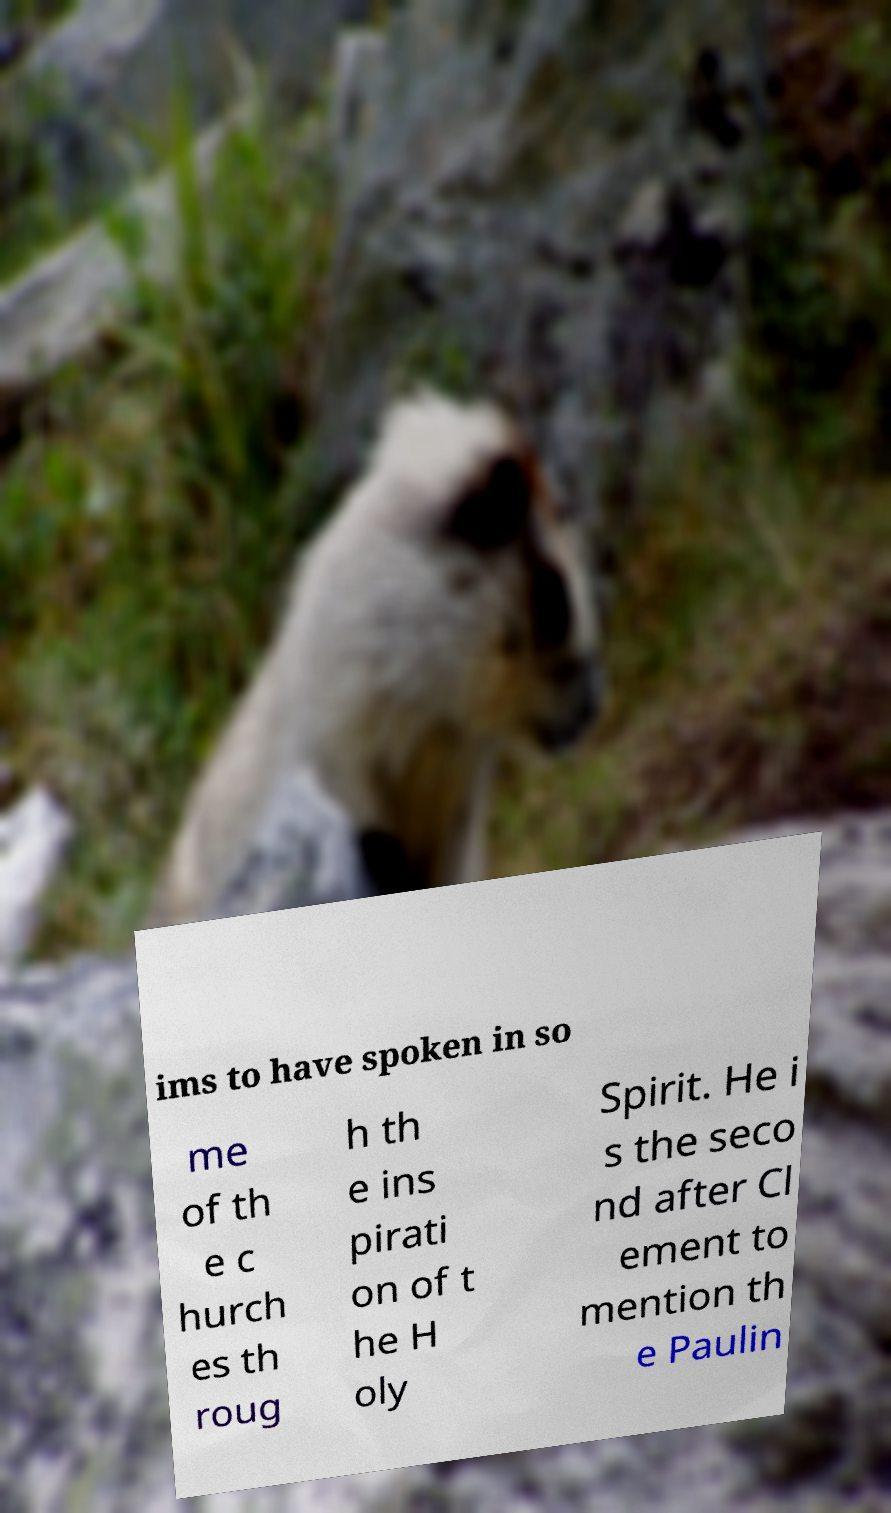Could you assist in decoding the text presented in this image and type it out clearly? ims to have spoken in so me of th e c hurch es th roug h th e ins pirati on of t he H oly Spirit. He i s the seco nd after Cl ement to mention th e Paulin 